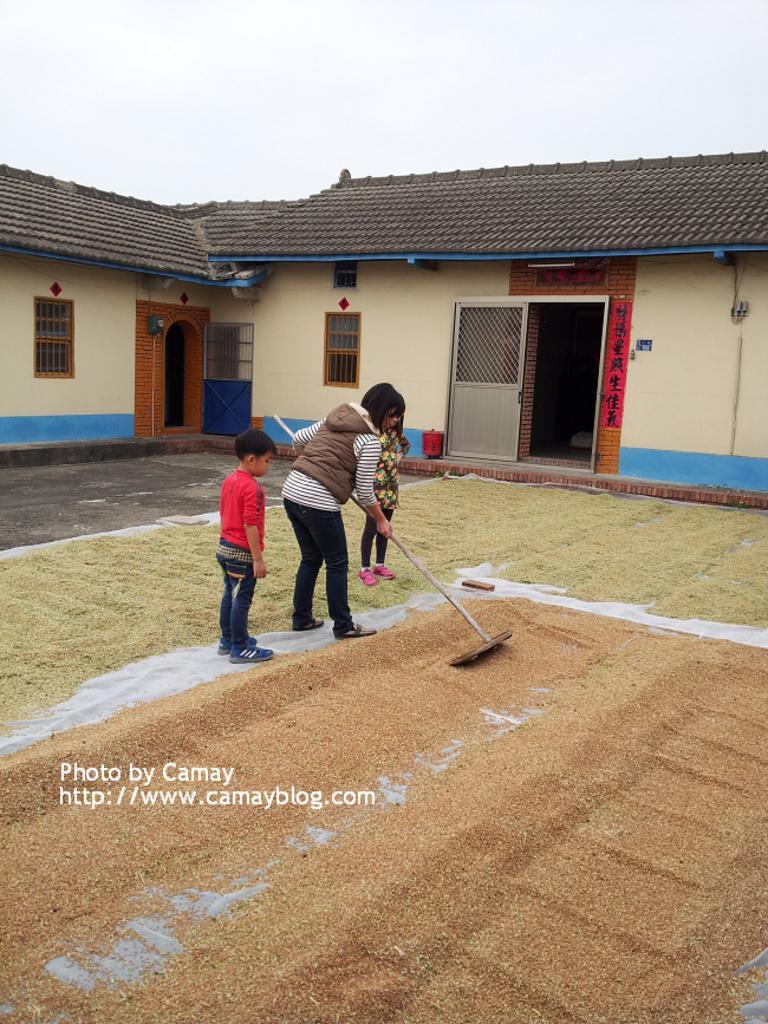How would you summarize this image in a sentence or two? In this image, we can see people and one of them is wearing a coat and holding a stick. In the background, we can see a house and there are doors. At the top, there is sky and at the bottom, there are grains and we can see some text. 